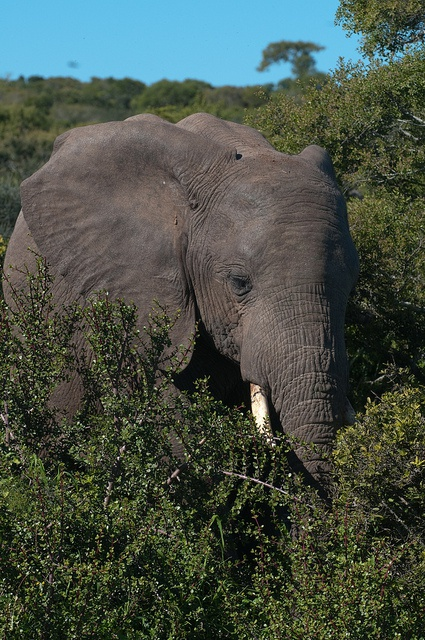Describe the objects in this image and their specific colors. I can see a elephant in lightblue, gray, black, and darkgreen tones in this image. 